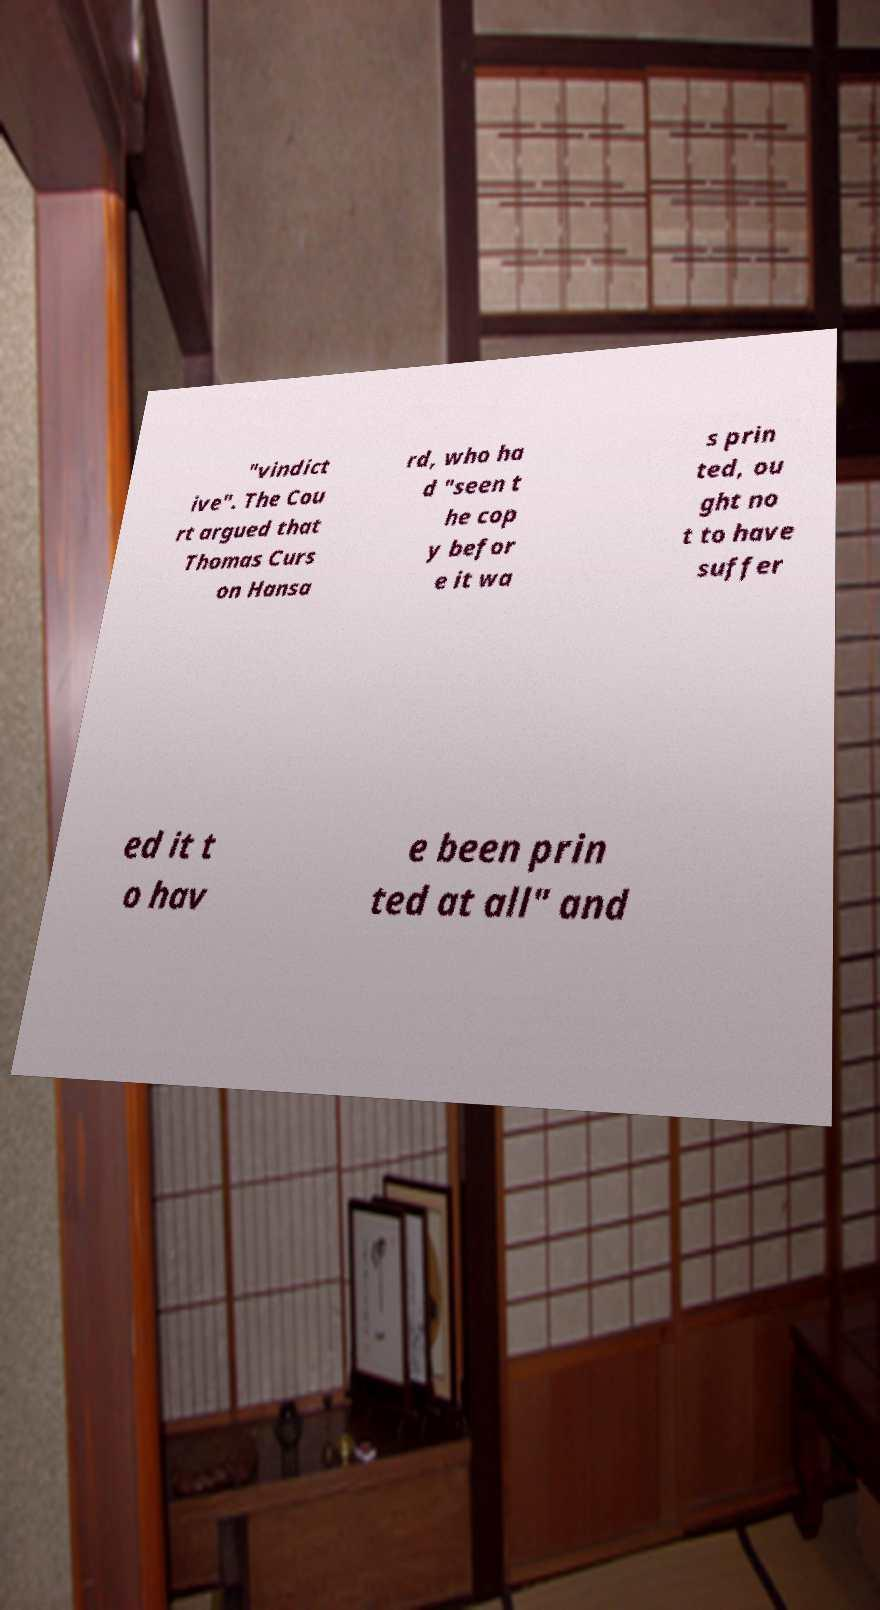For documentation purposes, I need the text within this image transcribed. Could you provide that? "vindict ive". The Cou rt argued that Thomas Curs on Hansa rd, who ha d "seen t he cop y befor e it wa s prin ted, ou ght no t to have suffer ed it t o hav e been prin ted at all" and 